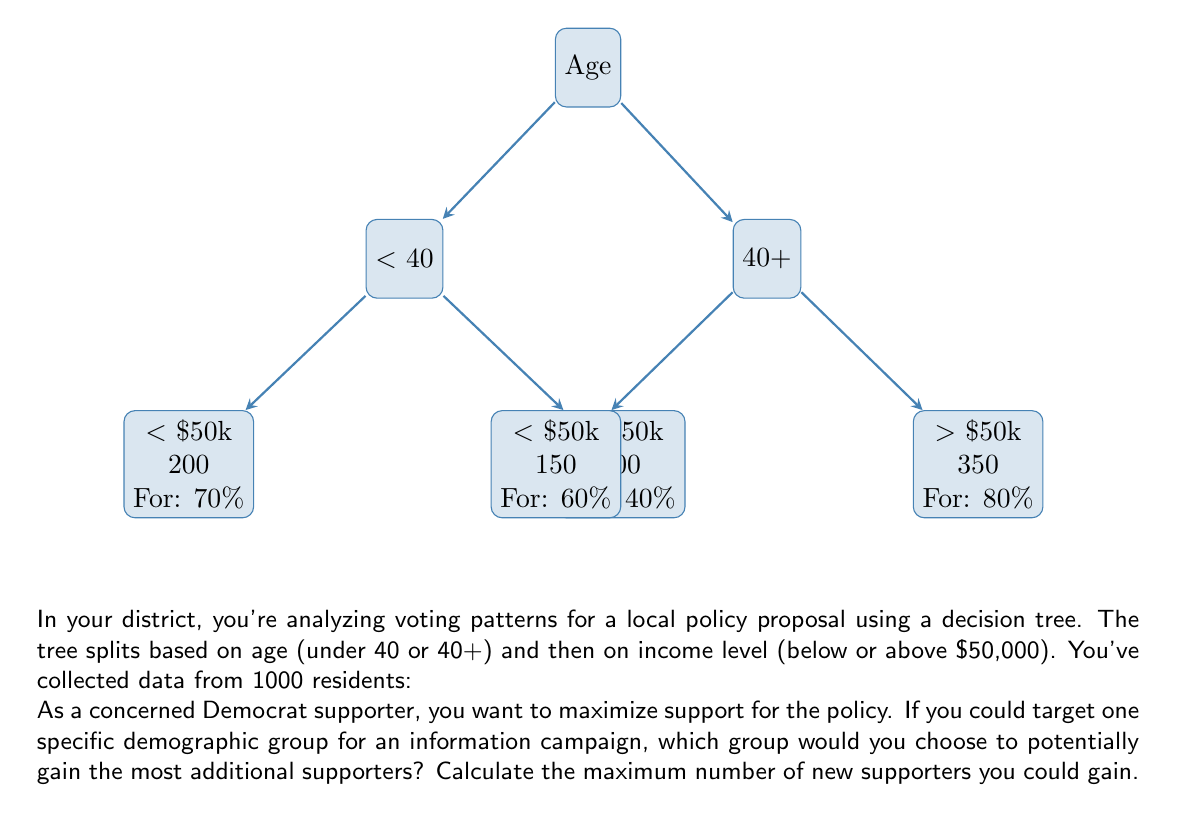Show me your answer to this math problem. Let's approach this step-by-step:

1) First, we need to calculate the current number of supporters in each group:

   Under 40, Income < $50k: $200 \times 0.70 = 140$ supporters
   Under 40, Income > $50k: $300 \times 0.40 = 120$ supporters
   40+, Income < $50k: $150 \times 0.60 = 90$ supporters
   40+, Income > $50k: $350 \times 0.80 = 280$ supporters

2) Now, let's calculate the potential gain if we could convince all members of each group:

   Under 40, Income < $50k: $200 - 140 = 60$ potential new supporters
   Under 40, Income > $50k: $300 - 120 = 180$ potential new supporters
   40+, Income < $50k: $150 - 90 = 60$ potential new supporters
   40+, Income > $50k: $350 - 280 = 70$ potential new supporters

3) The group with the highest potential gain is Under 40, Income > $50k, with 180 potential new supporters.

4) To verify:
   $$\max(60, 180, 60, 70) = 180$$

Therefore, targeting the group of residents under 40 with income over $50,000 would potentially gain the most additional supporters (180) for the policy proposal.
Answer: 180 new supporters from Under 40, Income > $50k group 